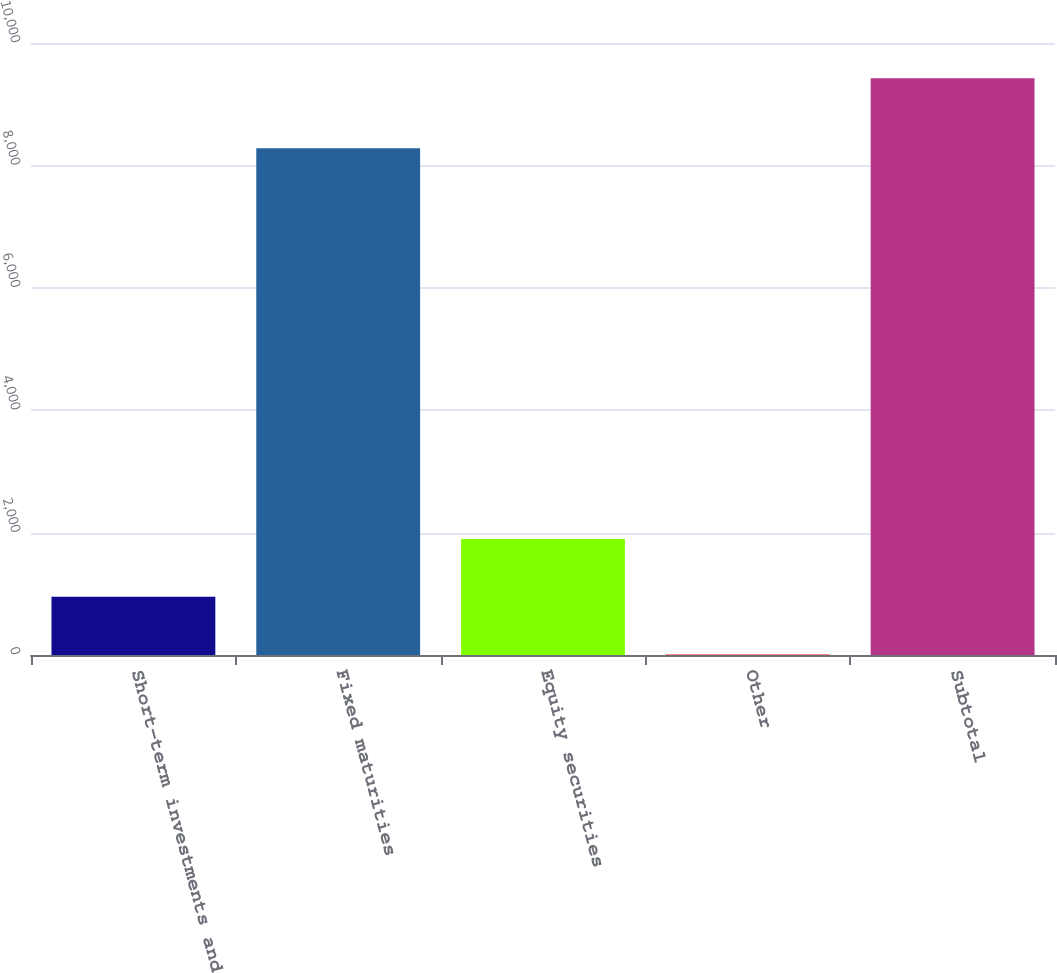<chart> <loc_0><loc_0><loc_500><loc_500><bar_chart><fcel>Short-term investments and<fcel>Fixed maturities<fcel>Equity securities<fcel>Other<fcel>Subtotal<nl><fcel>952.4<fcel>8282<fcel>1893.8<fcel>11<fcel>9425<nl></chart> 